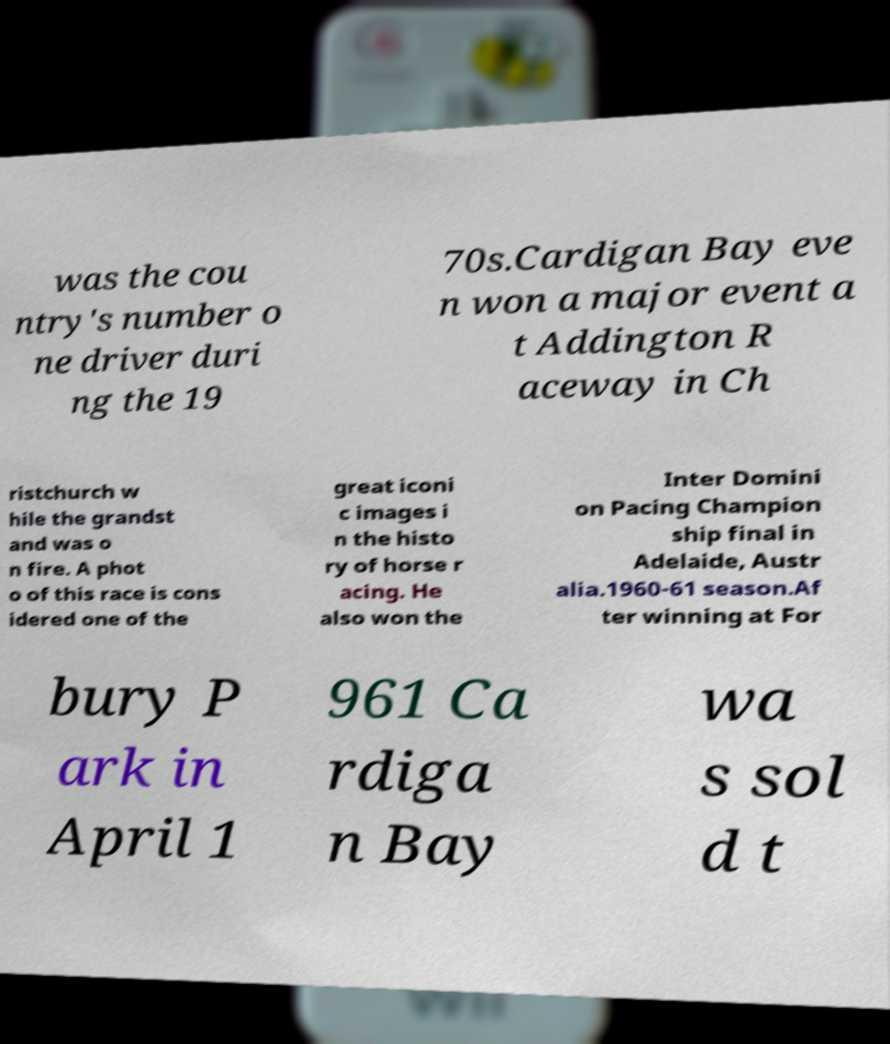Can you accurately transcribe the text from the provided image for me? was the cou ntry's number o ne driver duri ng the 19 70s.Cardigan Bay eve n won a major event a t Addington R aceway in Ch ristchurch w hile the grandst and was o n fire. A phot o of this race is cons idered one of the great iconi c images i n the histo ry of horse r acing. He also won the Inter Domini on Pacing Champion ship final in Adelaide, Austr alia.1960-61 season.Af ter winning at For bury P ark in April 1 961 Ca rdiga n Bay wa s sol d t 